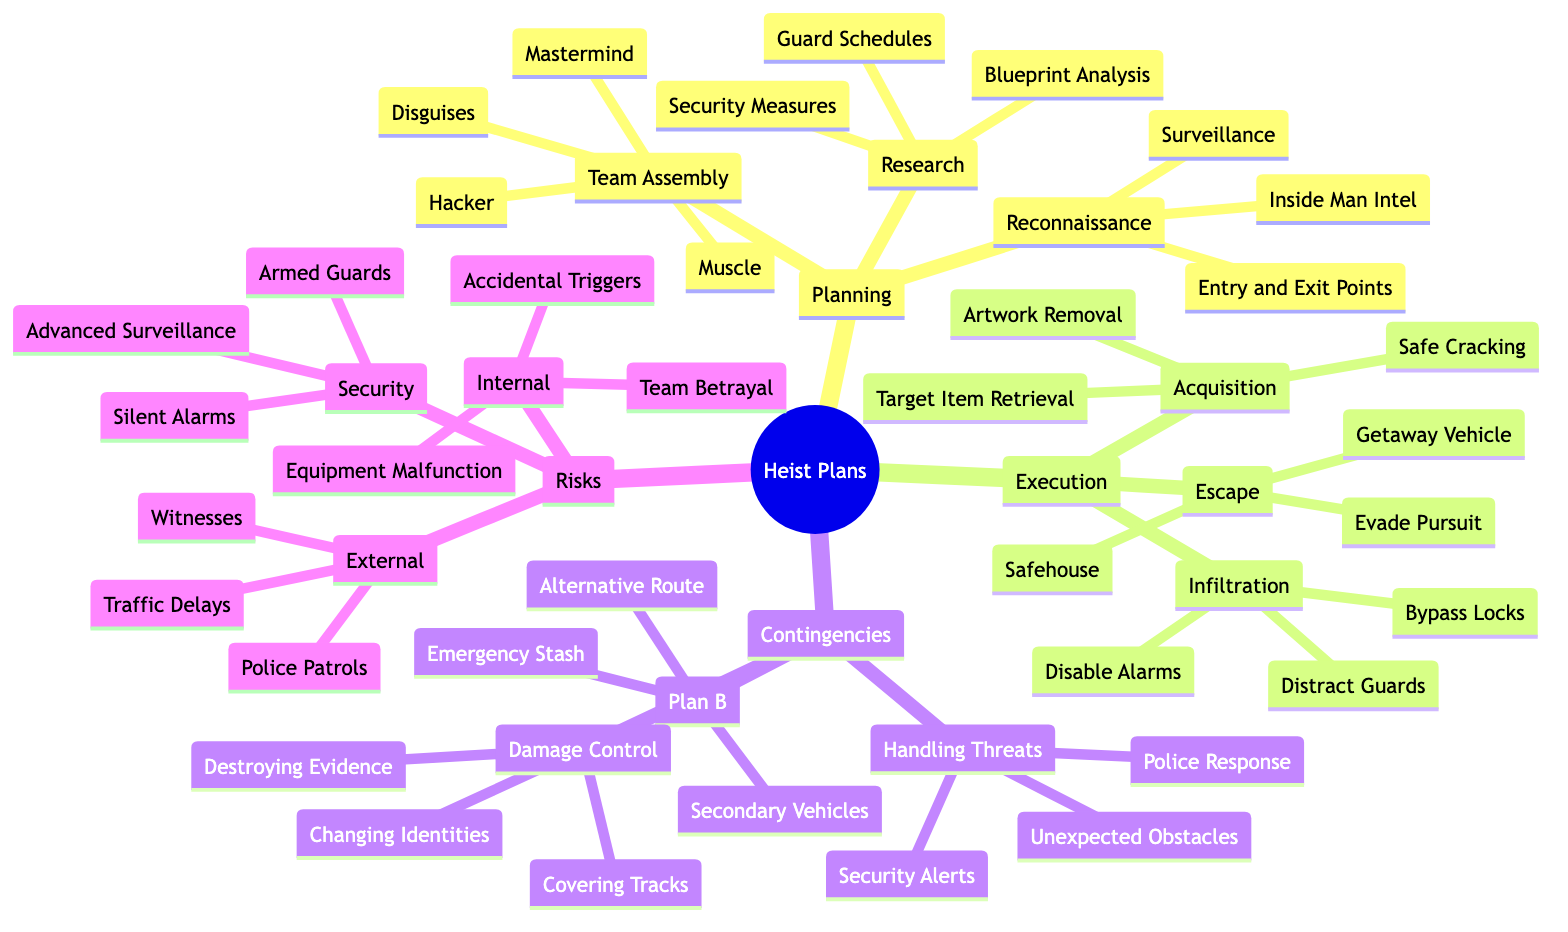What are the three main categories in the diagram? The diagram has four main categories, which are Planning, Execution, Contingencies, and Risks.
Answer: Planning, Execution, Contingencies, Risks How many sub-nodes are under the Execution node? The Execution node has three sub-nodes: Infiltration, Acquisition, and Escape. Therefore, there are three sub-nodes total.
Answer: 3 What is one risk under the Internal category? The Internal category of risks includes Team Betrayal, which is a single example of the risks mentioned.
Answer: Team Betrayal What are the three steps listed under Acquisition? The Acquisition step includes Safe Cracking, Artwork Removal, and Target Item Retrieval, which are the detailed actions to handle the objective.
Answer: Safe Cracking, Artwork Removal, Target Item Retrieval In the Contingencies section, what is one option found under Plan B? Under Plan B in the Contingencies section, one option listed is Alternative Route, showing a backup plan for the heist.
Answer: Alternative Route How many total risks are listed in the Security category? The Security category has three risks: Advanced Surveillance, Armed Guards, and Silent Alarms, providing a brief overview of potential security issues.
Answer: 3 Which node directly follows Team Assembly? Following Team Assembly, the next node is Reconnaissance, indicating the subsequent phase in the planning process.
Answer: Reconnaissance What is the primary purpose of the Infiltration sub-node? The primary purpose of Infiltration is to execute actions such as Disable Alarms, Distract Guards, and Bypass Locks, which are necessary to enter the target area undetected.
Answer: Disable Alarms, Distract Guards, Bypass Locks What does the Escape phase focus on? The Escape phase focuses on actions necessary for leaving the scene successfully, including Getaway Vehicle, Evade Pursuit, and Safehouse.
Answer: Getaway Vehicle, Evade Pursuit, Safehouse 